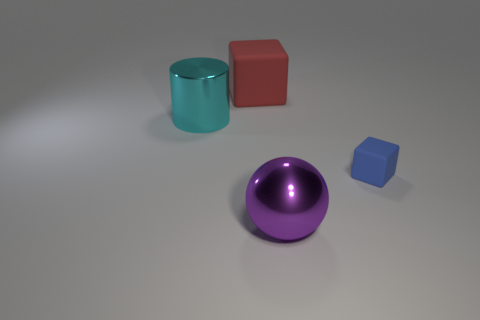Add 4 blue cubes. How many objects exist? 8 Subtract all spheres. How many objects are left? 3 Subtract all small blue things. Subtract all big red matte things. How many objects are left? 2 Add 3 purple balls. How many purple balls are left? 4 Add 4 large balls. How many large balls exist? 5 Subtract 0 gray balls. How many objects are left? 4 